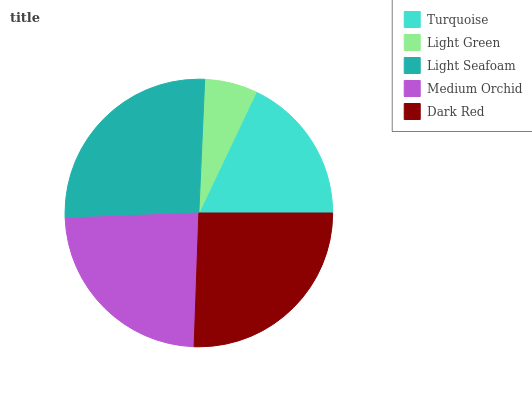Is Light Green the minimum?
Answer yes or no. Yes. Is Light Seafoam the maximum?
Answer yes or no. Yes. Is Light Seafoam the minimum?
Answer yes or no. No. Is Light Green the maximum?
Answer yes or no. No. Is Light Seafoam greater than Light Green?
Answer yes or no. Yes. Is Light Green less than Light Seafoam?
Answer yes or no. Yes. Is Light Green greater than Light Seafoam?
Answer yes or no. No. Is Light Seafoam less than Light Green?
Answer yes or no. No. Is Medium Orchid the high median?
Answer yes or no. Yes. Is Medium Orchid the low median?
Answer yes or no. Yes. Is Light Seafoam the high median?
Answer yes or no. No. Is Turquoise the low median?
Answer yes or no. No. 